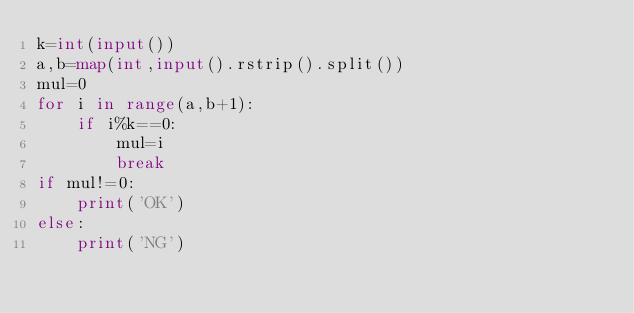<code> <loc_0><loc_0><loc_500><loc_500><_Python_>k=int(input())
a,b=map(int,input().rstrip().split())
mul=0
for i in range(a,b+1):
    if i%k==0:
        mul=i
        break
if mul!=0:
    print('OK')
else:
    print('NG')
    </code> 